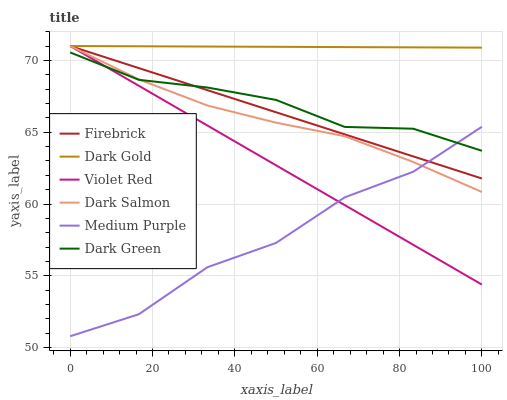Does Medium Purple have the minimum area under the curve?
Answer yes or no. Yes. Does Dark Gold have the maximum area under the curve?
Answer yes or no. Yes. Does Firebrick have the minimum area under the curve?
Answer yes or no. No. Does Firebrick have the maximum area under the curve?
Answer yes or no. No. Is Dark Gold the smoothest?
Answer yes or no. Yes. Is Medium Purple the roughest?
Answer yes or no. Yes. Is Firebrick the smoothest?
Answer yes or no. No. Is Firebrick the roughest?
Answer yes or no. No. Does Firebrick have the lowest value?
Answer yes or no. No. Does Dark Salmon have the highest value?
Answer yes or no. Yes. Does Medium Purple have the highest value?
Answer yes or no. No. Is Dark Green less than Dark Gold?
Answer yes or no. Yes. Is Dark Gold greater than Medium Purple?
Answer yes or no. Yes. Does Dark Green intersect Violet Red?
Answer yes or no. Yes. Is Dark Green less than Violet Red?
Answer yes or no. No. Is Dark Green greater than Violet Red?
Answer yes or no. No. Does Dark Green intersect Dark Gold?
Answer yes or no. No. 